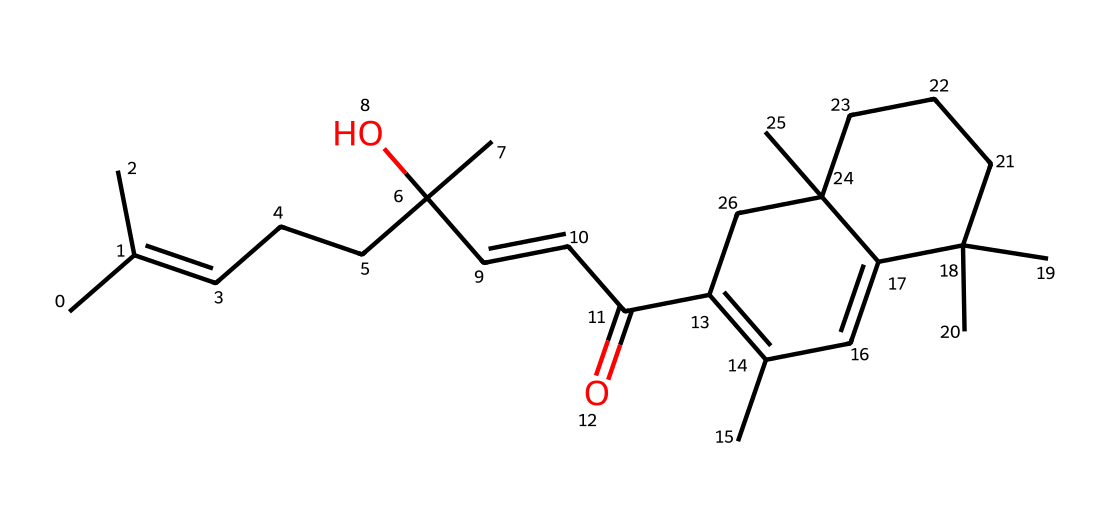how many carbon atoms are present in this molecule? To find the number of carbon atoms, one can count the 'C' symbols in the SMILES representation. Each 'C' stands for a carbon atom. In this case, there are 27 carbon atoms in total when counted.
Answer: 27 what is the functional group in this compound? The presence of the hydroxyl group (-OH) indicates that this compound contains an alcohol functional group. In the SMILES, the 'C)(O)' part signifies the alcohol group attached to a carbon, which is typical for resins.
Answer: alcohol what type of solid does this represent? This compound is a natural resin used in varnishes, which categorizes it as a polymeric solid or thermoplastic, thanks to its long chain structure. These properties make it suitable for applications in stringed instruments.
Answer: natural resin does this structure show signs of unsaturation? Yes, the presence of the double bonds, indicated by '=' symbols in the SMILES notation, reflects unsaturation. Unsaturation leads to more reactive sites in organic compounds like these resins.
Answer: yes which part of this chemical contributes to the sticky property of resins? The long hydrocarbon chains and the presence of functional groups like esters and alcohols contribute to the adhesive properties of resins. These segments allow for the intermolecular forces that provide stickiness.
Answer: hydrocarbon chains what is the degree of branching in this molecule? By analyzing the structure, one can identify multiple branches where tertiary and quaternary carbons are present. The presence of several branched alkyl groups indicates a high degree of branching.
Answer: high 